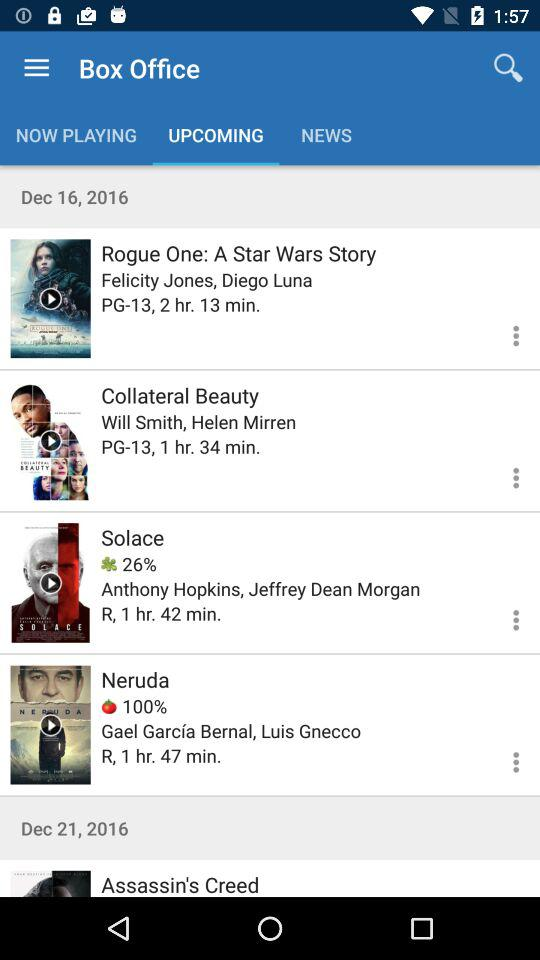How many movies have a user rating of 100%?
Answer the question using a single word or phrase. 1 